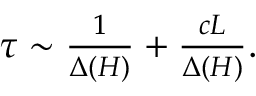Convert formula to latex. <formula><loc_0><loc_0><loc_500><loc_500>\begin{array} { r } { \tau \sim \frac { 1 } { \Delta ( H ) } + \frac { c L } { \Delta ( H ) } . } \end{array}</formula> 